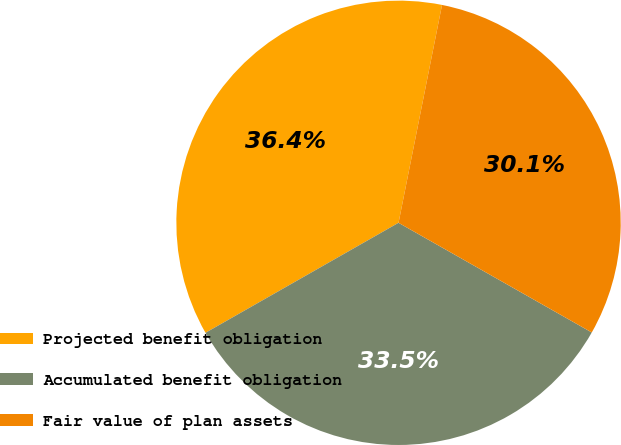Convert chart. <chart><loc_0><loc_0><loc_500><loc_500><pie_chart><fcel>Projected benefit obligation<fcel>Accumulated benefit obligation<fcel>Fair value of plan assets<nl><fcel>36.38%<fcel>33.54%<fcel>30.08%<nl></chart> 